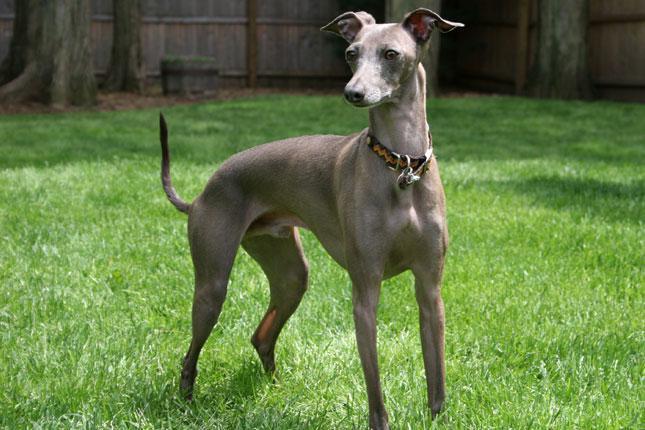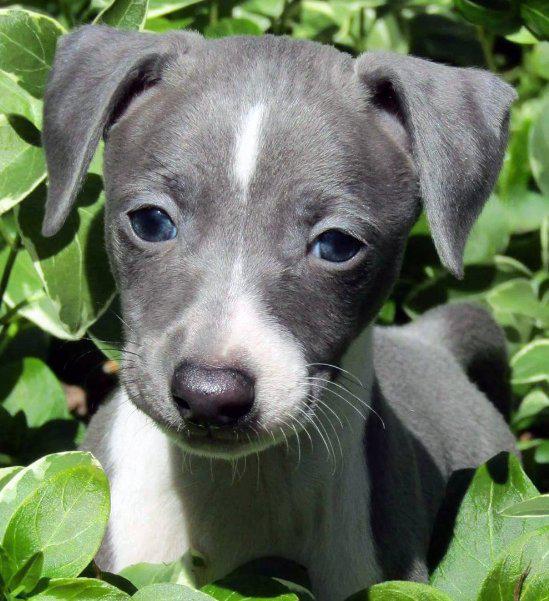The first image is the image on the left, the second image is the image on the right. Considering the images on both sides, is "In total, four dogs are shown." valid? Answer yes or no. No. The first image is the image on the left, the second image is the image on the right. Evaluate the accuracy of this statement regarding the images: "In one image, a person is holding at least one little dog.". Is it true? Answer yes or no. No. 